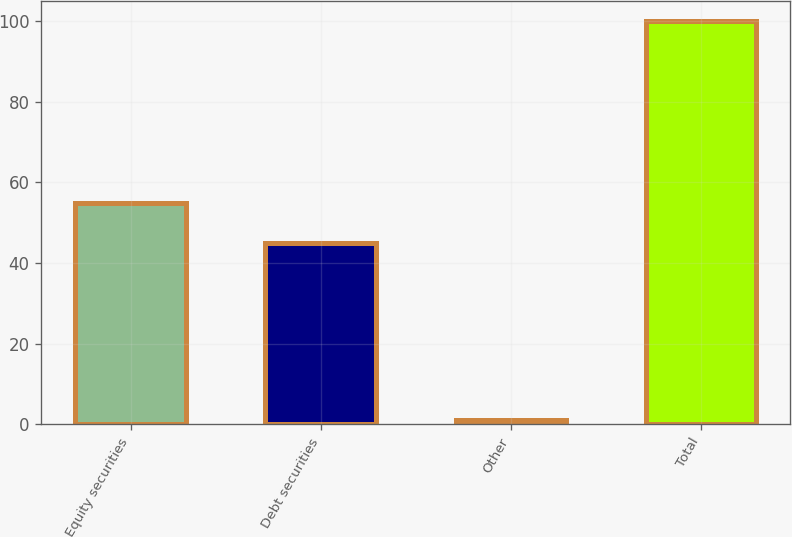<chart> <loc_0><loc_0><loc_500><loc_500><bar_chart><fcel>Equity securities<fcel>Debt securities<fcel>Other<fcel>Total<nl><fcel>54.9<fcel>45<fcel>1<fcel>100<nl></chart> 